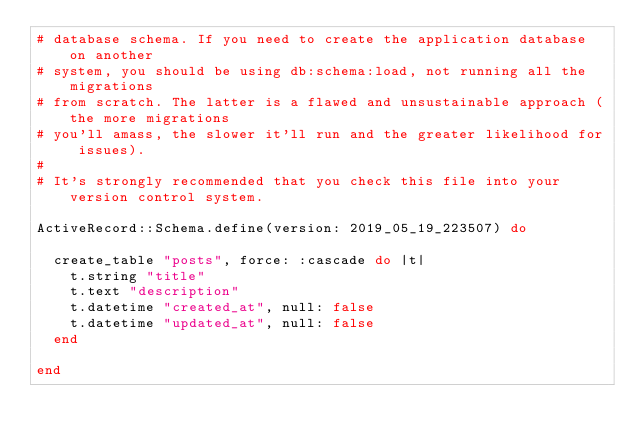<code> <loc_0><loc_0><loc_500><loc_500><_Ruby_># database schema. If you need to create the application database on another
# system, you should be using db:schema:load, not running all the migrations
# from scratch. The latter is a flawed and unsustainable approach (the more migrations
# you'll amass, the slower it'll run and the greater likelihood for issues).
#
# It's strongly recommended that you check this file into your version control system.

ActiveRecord::Schema.define(version: 2019_05_19_223507) do

  create_table "posts", force: :cascade do |t|
    t.string "title"
    t.text "description"
    t.datetime "created_at", null: false
    t.datetime "updated_at", null: false
  end

end
</code> 